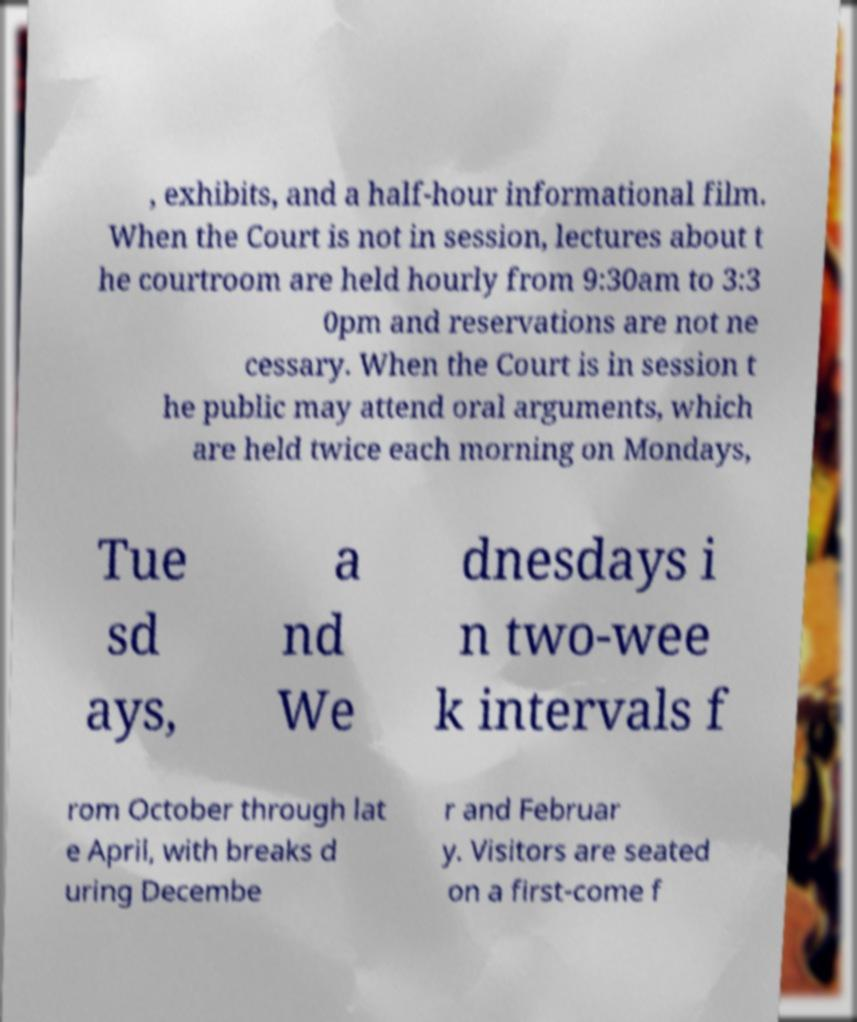Please read and relay the text visible in this image. What does it say? , exhibits, and a half-hour informational film. When the Court is not in session, lectures about t he courtroom are held hourly from 9:30am to 3:3 0pm and reservations are not ne cessary. When the Court is in session t he public may attend oral arguments, which are held twice each morning on Mondays, Tue sd ays, a nd We dnesdays i n two-wee k intervals f rom October through lat e April, with breaks d uring Decembe r and Februar y. Visitors are seated on a first-come f 